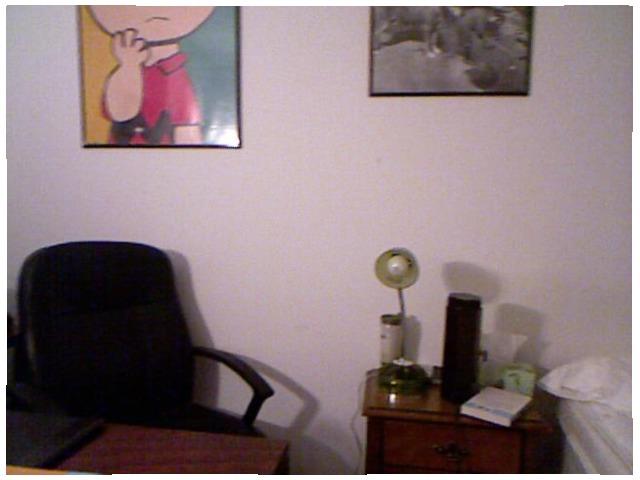<image>
Is there a book to the right of the lamp? Yes. From this viewpoint, the book is positioned to the right side relative to the lamp. 